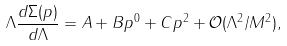Convert formula to latex. <formula><loc_0><loc_0><loc_500><loc_500>\Lambda \frac { d \Sigma ( p ) } { d \Lambda } = A + B p ^ { 0 } + C p ^ { 2 } + \mathcal { O } ( \Lambda ^ { 2 } / M ^ { 2 } ) ,</formula> 